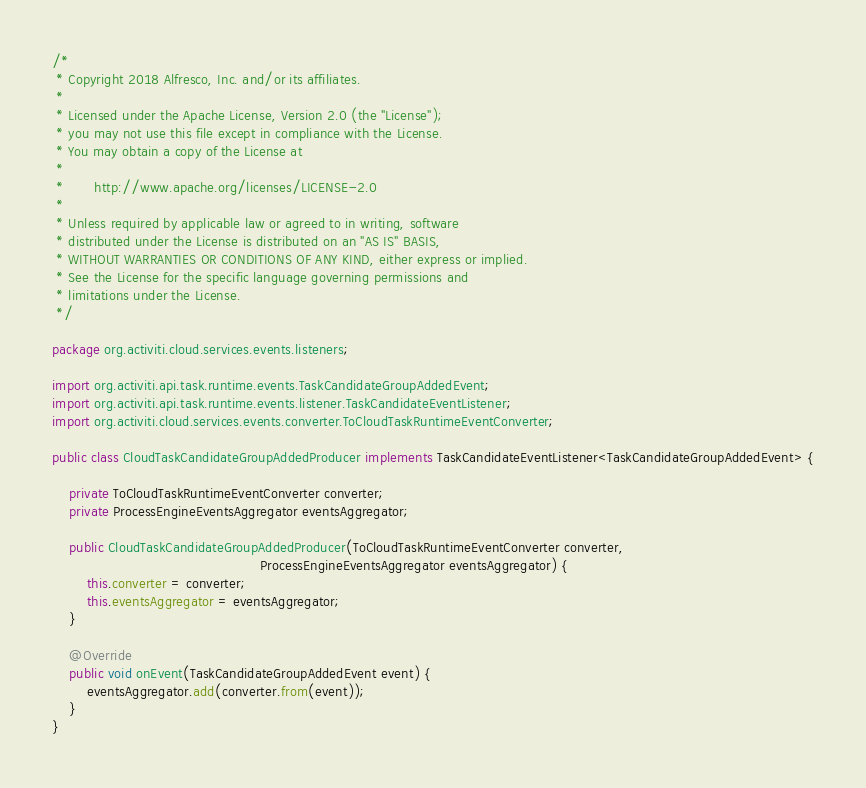<code> <loc_0><loc_0><loc_500><loc_500><_Java_>/*
 * Copyright 2018 Alfresco, Inc. and/or its affiliates.
 *
 * Licensed under the Apache License, Version 2.0 (the "License");
 * you may not use this file except in compliance with the License.
 * You may obtain a copy of the License at
 *
 *       http://www.apache.org/licenses/LICENSE-2.0
 *
 * Unless required by applicable law or agreed to in writing, software
 * distributed under the License is distributed on an "AS IS" BASIS,
 * WITHOUT WARRANTIES OR CONDITIONS OF ANY KIND, either express or implied.
 * See the License for the specific language governing permissions and
 * limitations under the License.
 */

package org.activiti.cloud.services.events.listeners;

import org.activiti.api.task.runtime.events.TaskCandidateGroupAddedEvent;
import org.activiti.api.task.runtime.events.listener.TaskCandidateEventListener;
import org.activiti.cloud.services.events.converter.ToCloudTaskRuntimeEventConverter;

public class CloudTaskCandidateGroupAddedProducer implements TaskCandidateEventListener<TaskCandidateGroupAddedEvent> {

    private ToCloudTaskRuntimeEventConverter converter;
    private ProcessEngineEventsAggregator eventsAggregator;

    public CloudTaskCandidateGroupAddedProducer(ToCloudTaskRuntimeEventConverter converter,
                                                ProcessEngineEventsAggregator eventsAggregator) {
        this.converter = converter;
        this.eventsAggregator = eventsAggregator;
    }

    @Override
    public void onEvent(TaskCandidateGroupAddedEvent event) {
        eventsAggregator.add(converter.from(event));
    }
}
</code> 